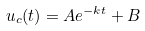<formula> <loc_0><loc_0><loc_500><loc_500>u _ { c } ( t ) = A e ^ { - k t } + B</formula> 